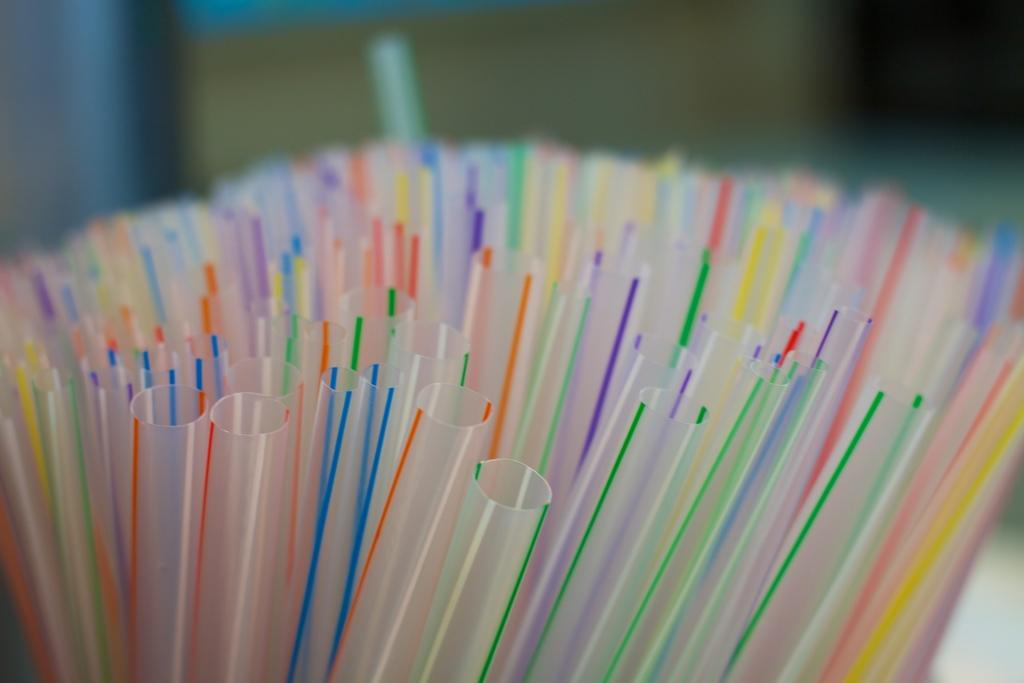What objects can be seen in the image? There are straws in the image. Can you describe the background of the image? The background of the image is blurry. What type of plate is used to serve the dish in the image? There is no dish or plate present in the image; it only features straws. What kind of design can be seen on the instrument in the image? There is no instrument present in the image, only straws. 